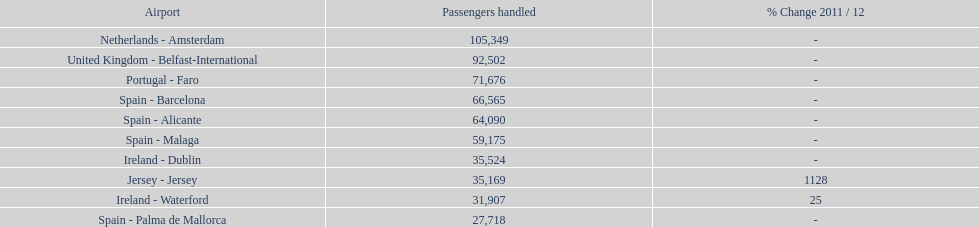Which airport dealt with no more than 30,000 passengers on the 10 busiest routes to and from london southend airport in 2012? Spain - Palma de Mallorca. 